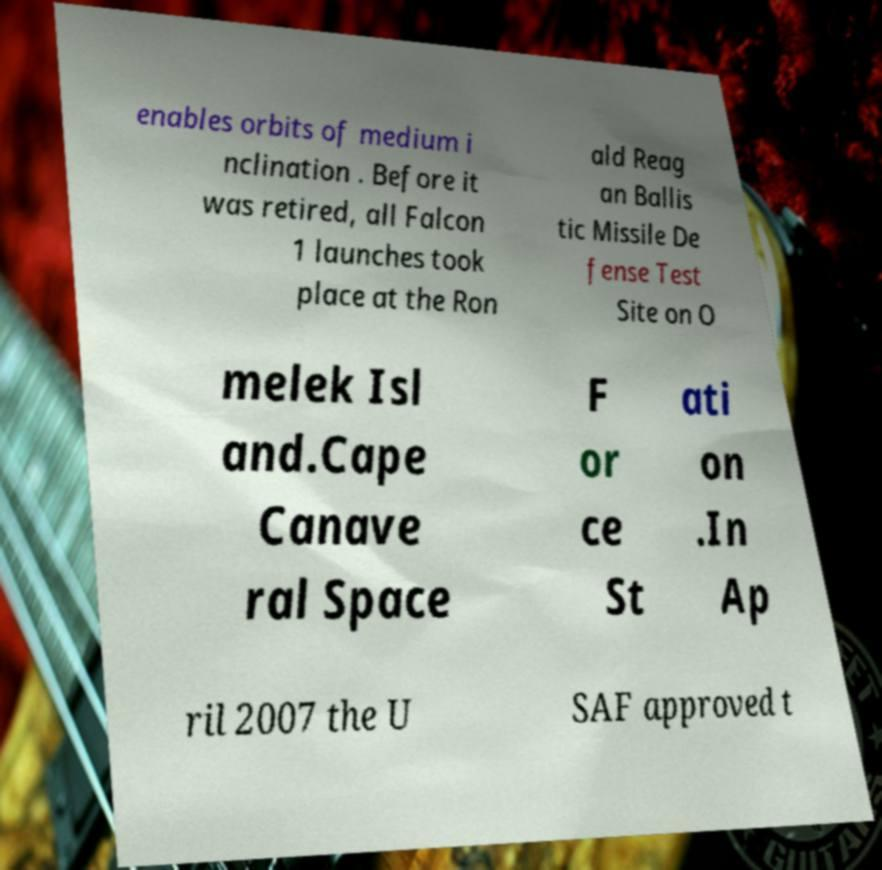I need the written content from this picture converted into text. Can you do that? enables orbits of medium i nclination . Before it was retired, all Falcon 1 launches took place at the Ron ald Reag an Ballis tic Missile De fense Test Site on O melek Isl and.Cape Canave ral Space F or ce St ati on .In Ap ril 2007 the U SAF approved t 